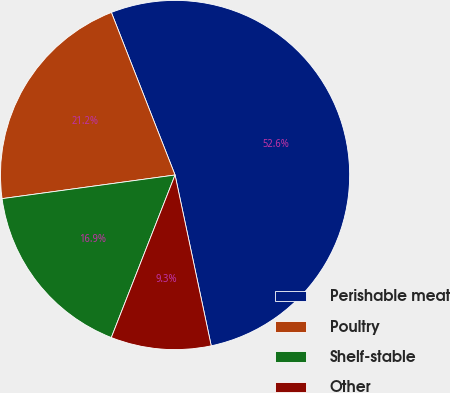<chart> <loc_0><loc_0><loc_500><loc_500><pie_chart><fcel>Perishable meat<fcel>Poultry<fcel>Shelf-stable<fcel>Other<nl><fcel>52.62%<fcel>21.22%<fcel>16.89%<fcel>9.27%<nl></chart> 